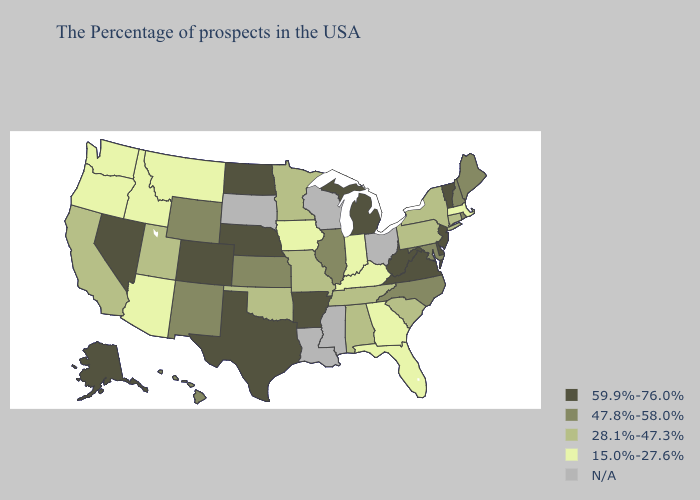Name the states that have a value in the range 47.8%-58.0%?
Keep it brief. Maine, Rhode Island, New Hampshire, Maryland, North Carolina, Illinois, Kansas, Wyoming, New Mexico, Hawaii. Does New Mexico have the lowest value in the USA?
Give a very brief answer. No. What is the lowest value in the South?
Concise answer only. 15.0%-27.6%. Name the states that have a value in the range 15.0%-27.6%?
Short answer required. Massachusetts, Florida, Georgia, Kentucky, Indiana, Iowa, Montana, Arizona, Idaho, Washington, Oregon. What is the value of Michigan?
Answer briefly. 59.9%-76.0%. Which states hav the highest value in the MidWest?
Short answer required. Michigan, Nebraska, North Dakota. Name the states that have a value in the range 47.8%-58.0%?
Concise answer only. Maine, Rhode Island, New Hampshire, Maryland, North Carolina, Illinois, Kansas, Wyoming, New Mexico, Hawaii. Which states hav the highest value in the Northeast?
Short answer required. Vermont, New Jersey. Does Wyoming have the lowest value in the West?
Give a very brief answer. No. What is the highest value in the South ?
Give a very brief answer. 59.9%-76.0%. What is the highest value in the USA?
Keep it brief. 59.9%-76.0%. Name the states that have a value in the range 15.0%-27.6%?
Be succinct. Massachusetts, Florida, Georgia, Kentucky, Indiana, Iowa, Montana, Arizona, Idaho, Washington, Oregon. Among the states that border Vermont , which have the lowest value?
Quick response, please. Massachusetts. Does Indiana have the lowest value in the USA?
Write a very short answer. Yes. What is the lowest value in the USA?
Give a very brief answer. 15.0%-27.6%. 